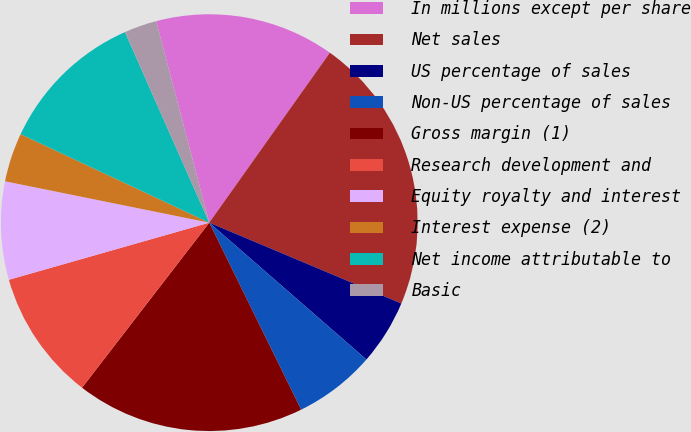<chart> <loc_0><loc_0><loc_500><loc_500><pie_chart><fcel>In millions except per share<fcel>Net sales<fcel>US percentage of sales<fcel>Non-US percentage of sales<fcel>Gross margin (1)<fcel>Research development and<fcel>Equity royalty and interest<fcel>Interest expense (2)<fcel>Net income attributable to<fcel>Basic<nl><fcel>13.92%<fcel>21.52%<fcel>5.06%<fcel>6.33%<fcel>17.72%<fcel>10.13%<fcel>7.6%<fcel>3.8%<fcel>11.39%<fcel>2.53%<nl></chart> 